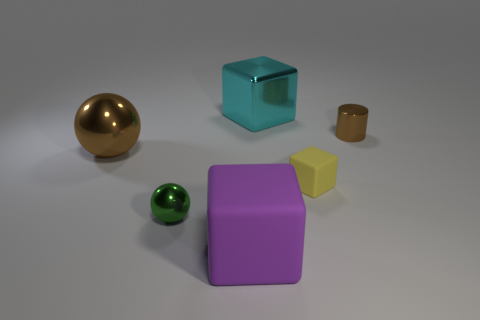Subtract all big cubes. How many cubes are left? 1 Add 3 large yellow matte blocks. How many objects exist? 9 Subtract 2 cubes. How many cubes are left? 1 Add 6 large purple blocks. How many large purple blocks exist? 7 Subtract all brown spheres. How many spheres are left? 1 Subtract 1 brown balls. How many objects are left? 5 Subtract all spheres. How many objects are left? 4 Subtract all red cubes. Subtract all brown spheres. How many cubes are left? 3 Subtract all brown cubes. How many brown balls are left? 1 Subtract all tiny yellow things. Subtract all small shiny cylinders. How many objects are left? 4 